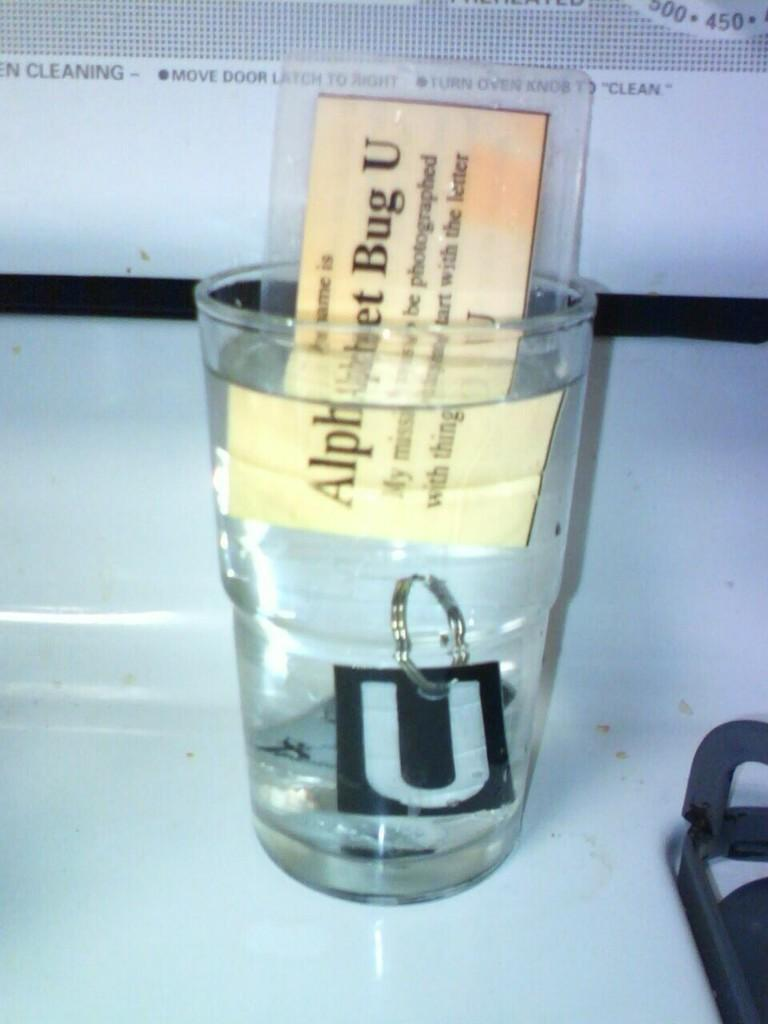<image>
Write a terse but informative summary of the picture. A glass full of water has a card in it that says Alphabet Bug U. 